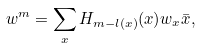<formula> <loc_0><loc_0><loc_500><loc_500>w ^ { m } = \sum _ { x } H _ { m - l ( x ) } ( x ) w _ { x } \bar { x } ,</formula> 